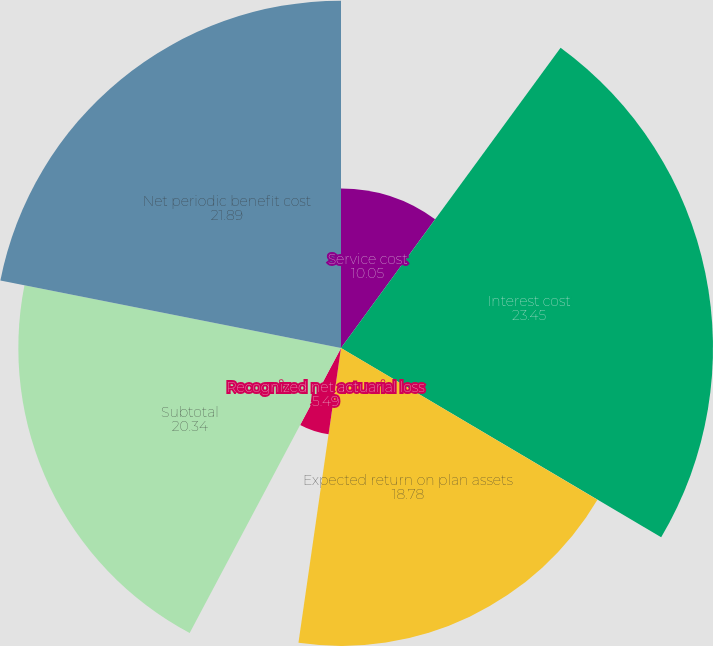<chart> <loc_0><loc_0><loc_500><loc_500><pie_chart><fcel>Service cost<fcel>Interest cost<fcel>Expected return on plan assets<fcel>Recognized net actuarial loss<fcel>Subtotal<fcel>Net periodic benefit cost<nl><fcel>10.05%<fcel>23.45%<fcel>18.78%<fcel>5.49%<fcel>20.34%<fcel>21.89%<nl></chart> 